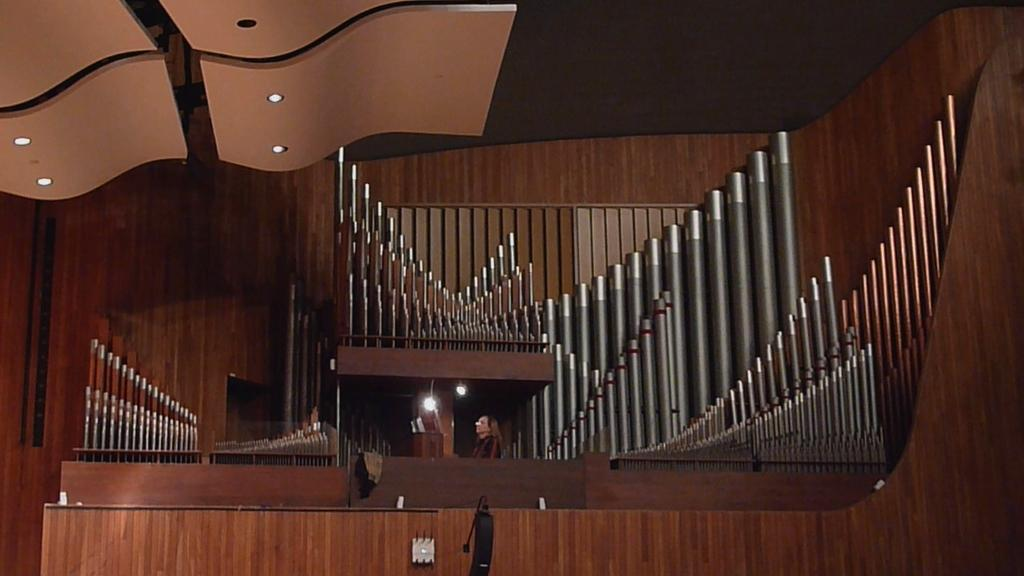Where is the location of the image? The image is inside a building. What type of material is used for the wall in the image? There is a wooden wall in the image. Can you describe the architectural features visible in the image? The architecture is visible in the image. Who or what can be seen in the image? There is a person in the image. What is present at the top of the image? Lights are present at the top of the image. What type of badge is the person wearing in the image? There is no badge visible in the image. What color is the yarn used to create the person's clothing in the image? There is no yarn or clothing visible in the image, as it is a person inside a building with a wooden wall and lights. 